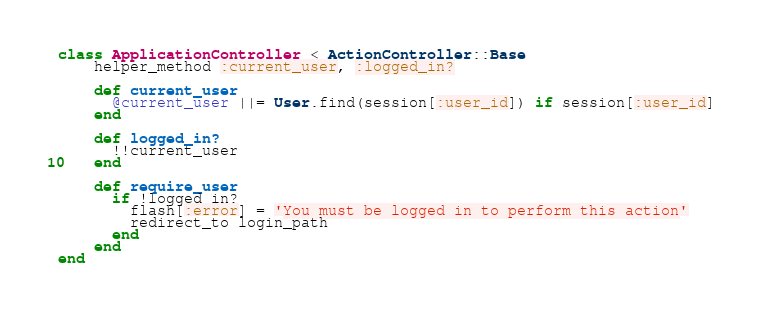<code> <loc_0><loc_0><loc_500><loc_500><_Ruby_>class ApplicationController < ActionController::Base
    helper_method :current_user, :logged_in?

    def current_user
      @current_user ||= User.find(session[:user_id]) if session[:user_id]
    end

    def logged_in?
      !!current_user
    end

    def require_user
      if !logged_in?
        flash[:error] = 'You must be logged in to perform this action'
        redirect_to login_path
      end
    end
end
</code> 